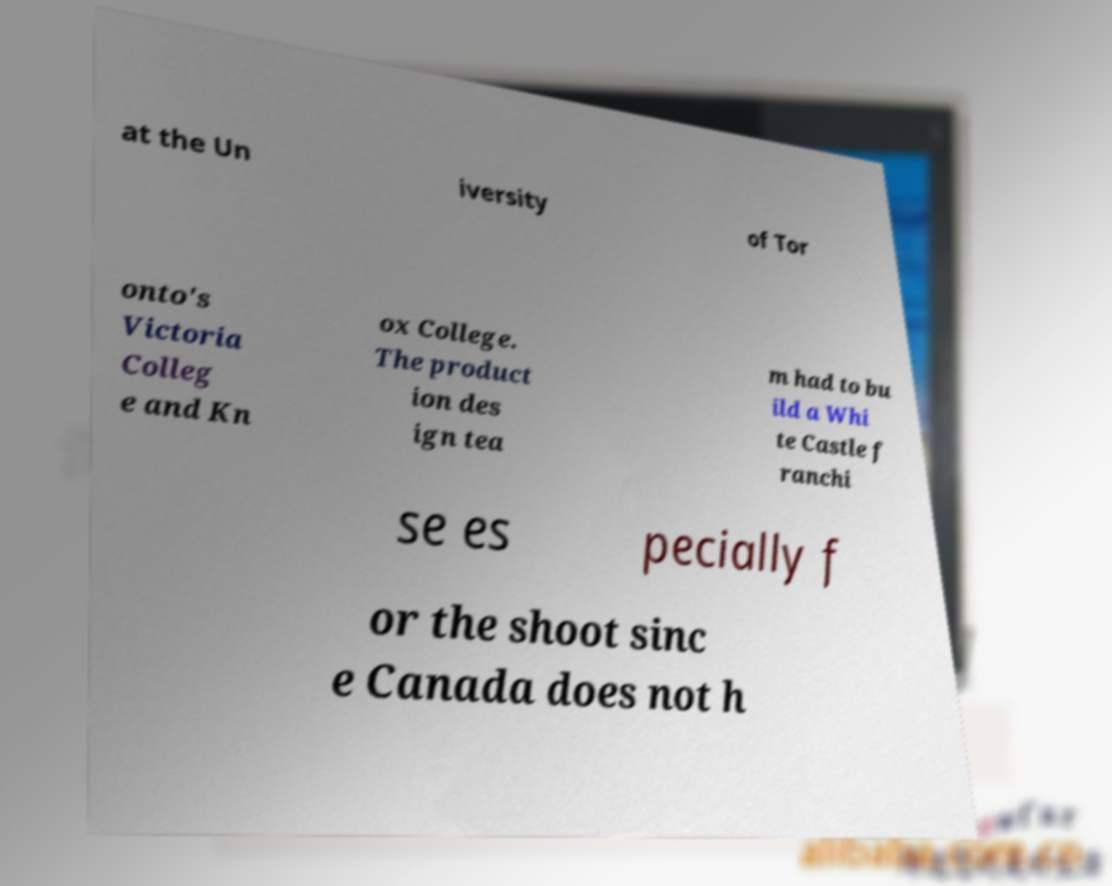Could you extract and type out the text from this image? at the Un iversity of Tor onto's Victoria Colleg e and Kn ox College. The product ion des ign tea m had to bu ild a Whi te Castle f ranchi se es pecially f or the shoot sinc e Canada does not h 